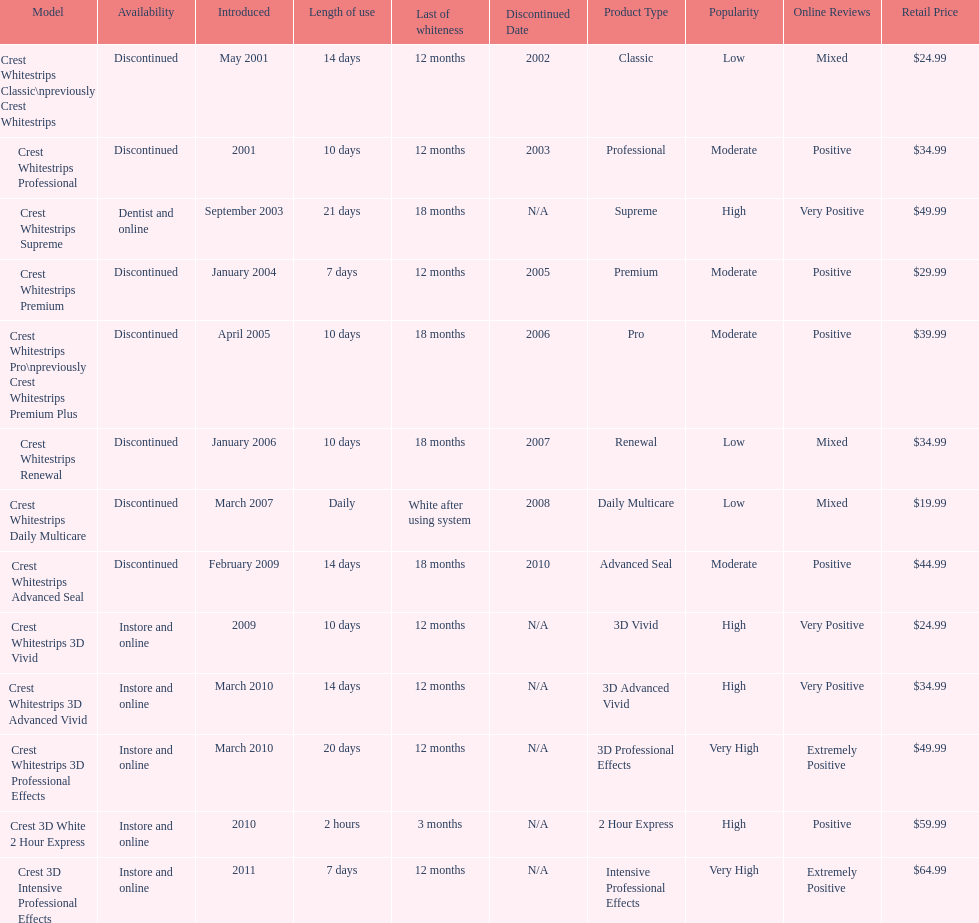Which product was to be used longer, crest whitestrips classic or crest whitestrips 3d vivid? Crest Whitestrips Classic. 